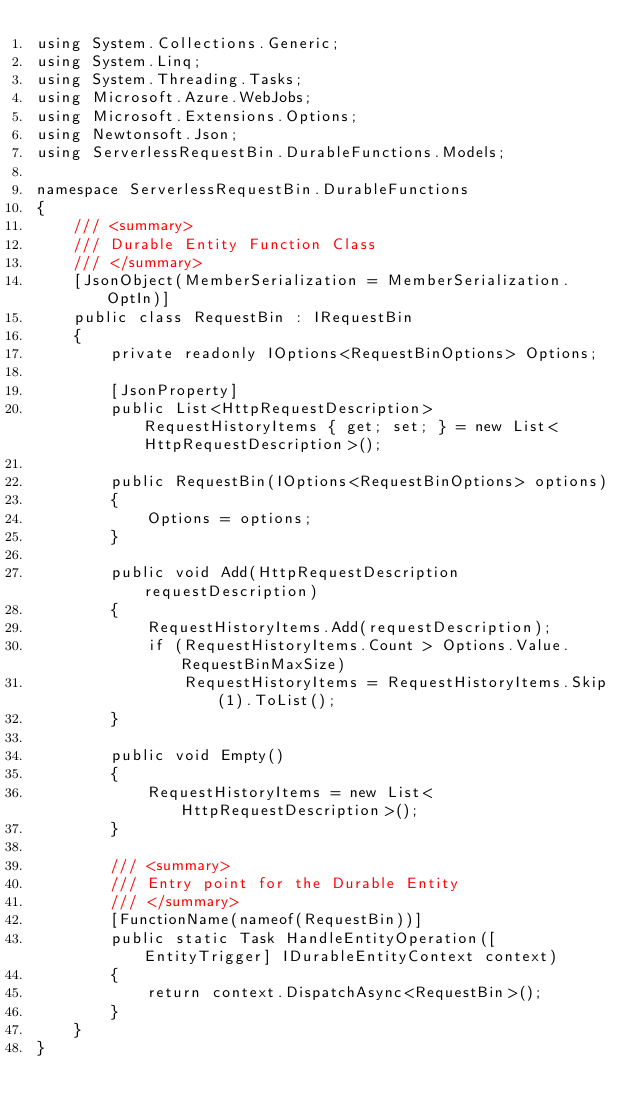<code> <loc_0><loc_0><loc_500><loc_500><_C#_>using System.Collections.Generic;
using System.Linq;
using System.Threading.Tasks;
using Microsoft.Azure.WebJobs;
using Microsoft.Extensions.Options;
using Newtonsoft.Json;
using ServerlessRequestBin.DurableFunctions.Models;

namespace ServerlessRequestBin.DurableFunctions
{
    /// <summary>
    /// Durable Entity Function Class
    /// </summary>
    [JsonObject(MemberSerialization = MemberSerialization.OptIn)]
    public class RequestBin : IRequestBin
    {
        private readonly IOptions<RequestBinOptions> Options;

        [JsonProperty]
        public List<HttpRequestDescription> RequestHistoryItems { get; set; } = new List<HttpRequestDescription>();

        public RequestBin(IOptions<RequestBinOptions> options)
        {
            Options = options;
        }

        public void Add(HttpRequestDescription requestDescription)
        {
            RequestHistoryItems.Add(requestDescription);
            if (RequestHistoryItems.Count > Options.Value.RequestBinMaxSize)
                RequestHistoryItems = RequestHistoryItems.Skip(1).ToList();
        }

        public void Empty()
        {
            RequestHistoryItems = new List<HttpRequestDescription>();
        }

        /// <summary>
        /// Entry point for the Durable Entity
        /// </summary>
        [FunctionName(nameof(RequestBin))]
        public static Task HandleEntityOperation([EntityTrigger] IDurableEntityContext context)
        {
            return context.DispatchAsync<RequestBin>();
        }
    }
}</code> 